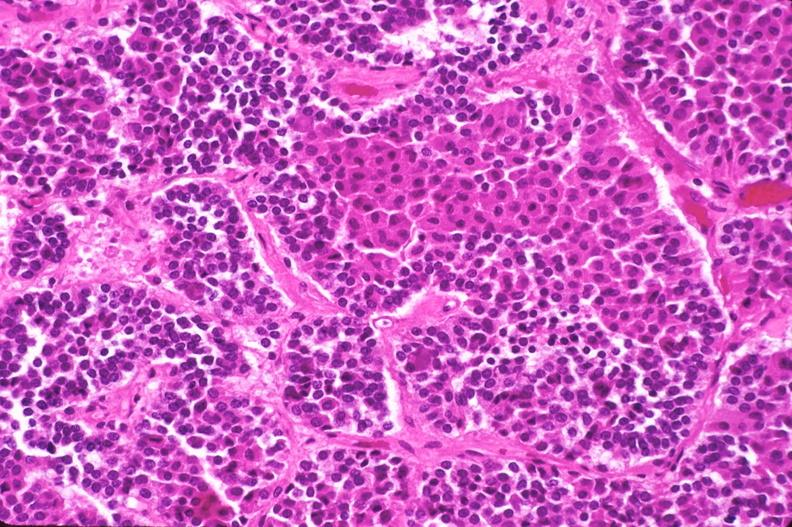s this image present?
Answer the question using a single word or phrase. No 